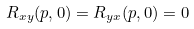Convert formula to latex. <formula><loc_0><loc_0><loc_500><loc_500>R _ { x y } ( { p } , 0 ) = R _ { y x } ( { p } , 0 ) = 0</formula> 